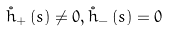Convert formula to latex. <formula><loc_0><loc_0><loc_500><loc_500>\mathring { h } _ { + } \left ( s \right ) \neq 0 , \mathring { h } _ { - } \left ( s \right ) = 0</formula> 